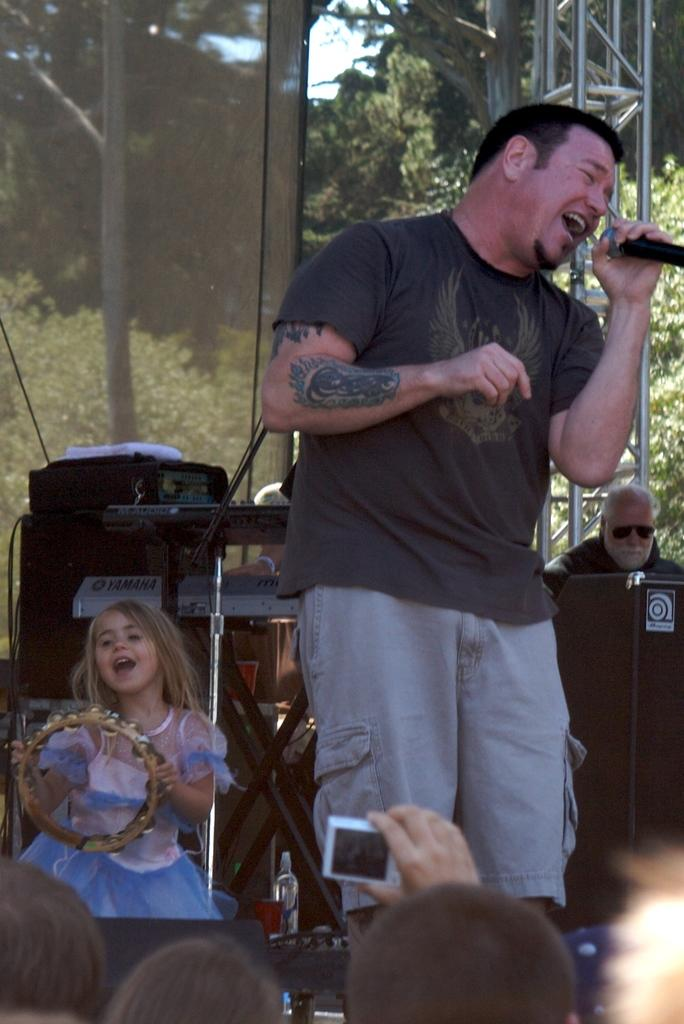What is the man in the image doing? The man is singing in the image. What object is the man holding while singing? The man is holding a microphone. Who else is present in the image besides the man? There is a girl in the image. What is the girl doing in the image? The girl is playing a musical instrument. What type of hat is the girl wearing in the image? There is no hat present in the image; the girl is playing a musical instrument. 